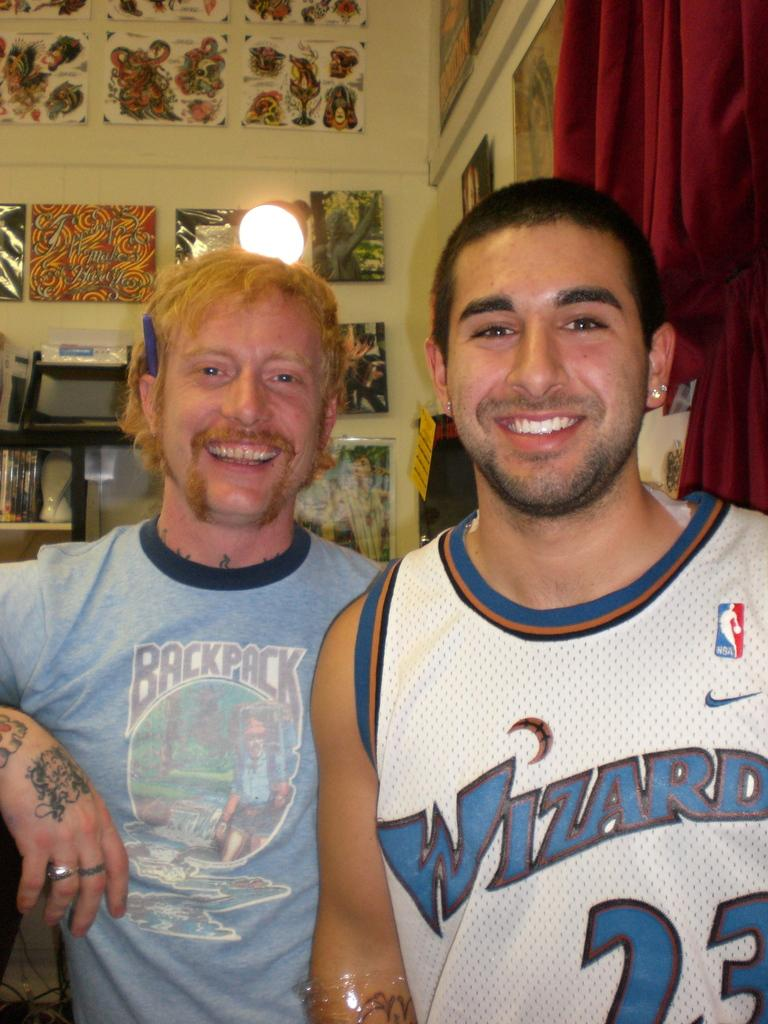<image>
Present a compact description of the photo's key features. Man wearing a Wizards jersey posing with another man. 